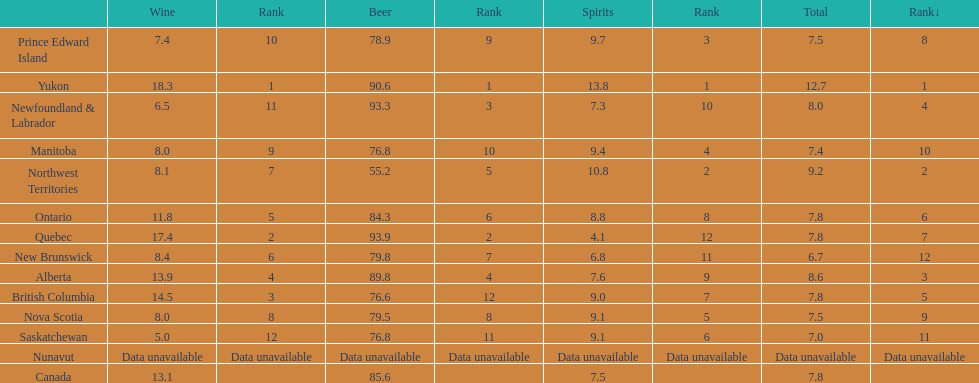Which canadian territory had a beer consumption of 93.9? Quebec. What was their consumption of spirits? 4.1. 